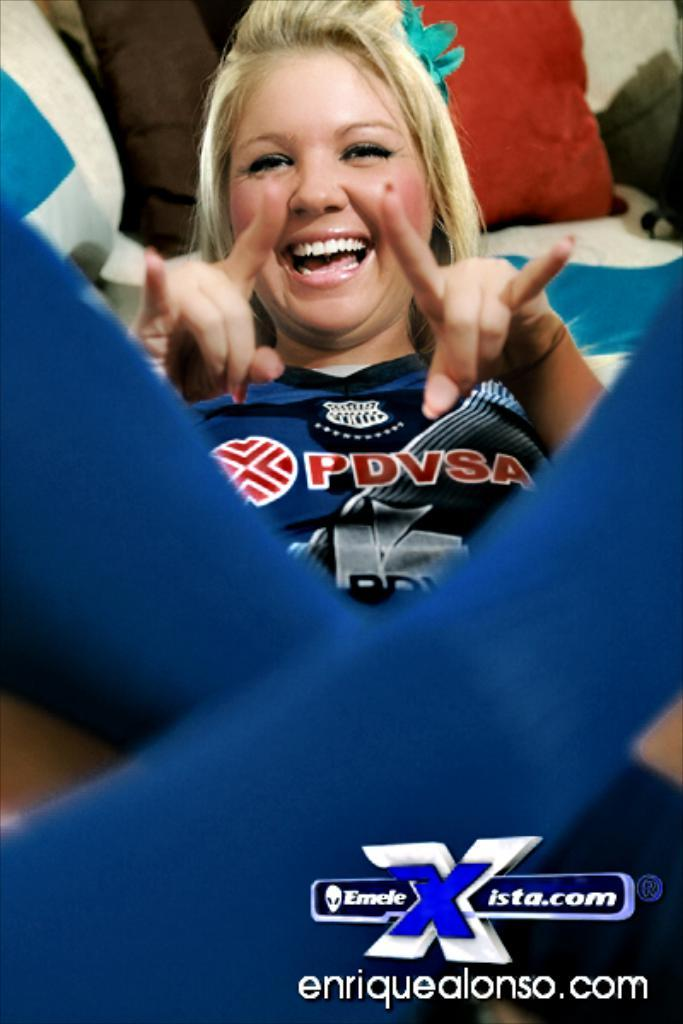<image>
Render a clear and concise summary of the photo. A blond woman is wearing a PDVSA jersey. 